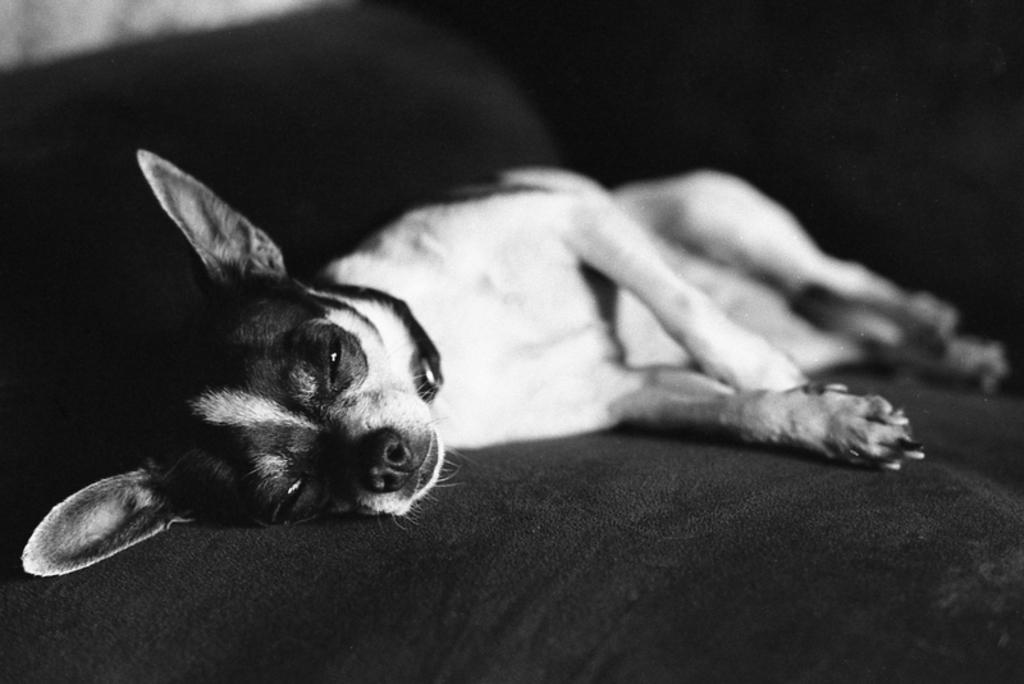What animal is present in the image? There is a dog in the image. Where is the dog located? The dog is lying on a couch. What color is the couch? The couch is black. What is the color scheme of the image? The image is black and white. What type of cub can be seen playing with a clock in the image? There is no cub or clock present in the image; it features a dog lying on a black couch. 